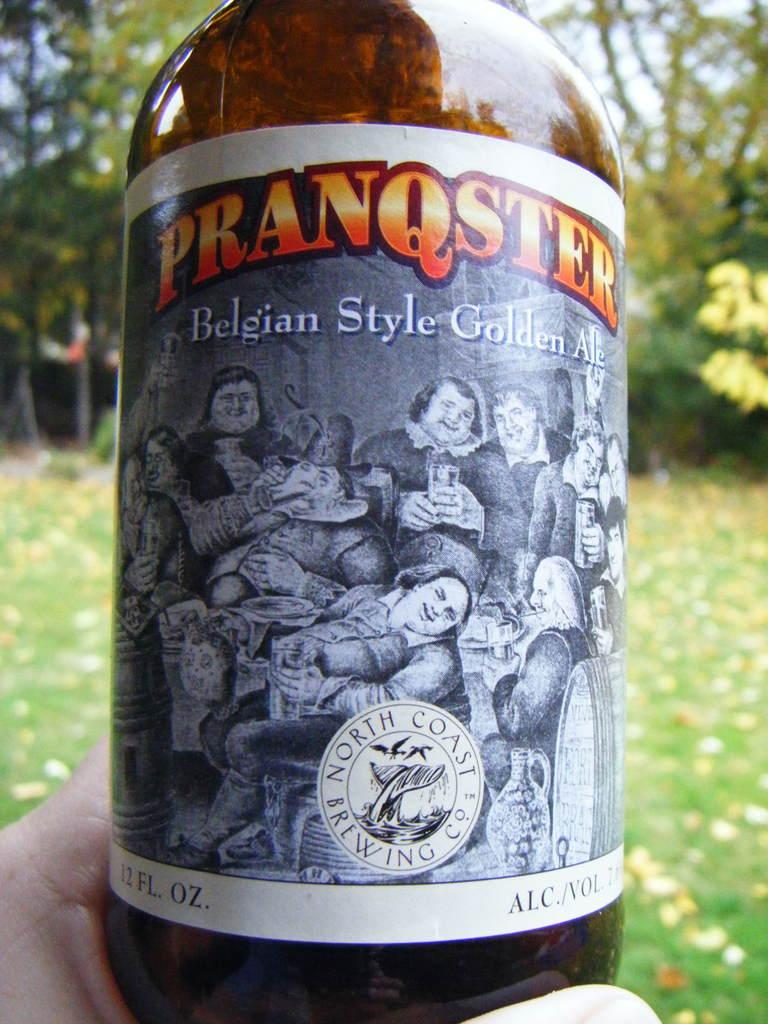<image>
Provide a brief description of the given image. Someone is enjoying a Pranqster Belgian Style Golden Ale on a sunny day. 